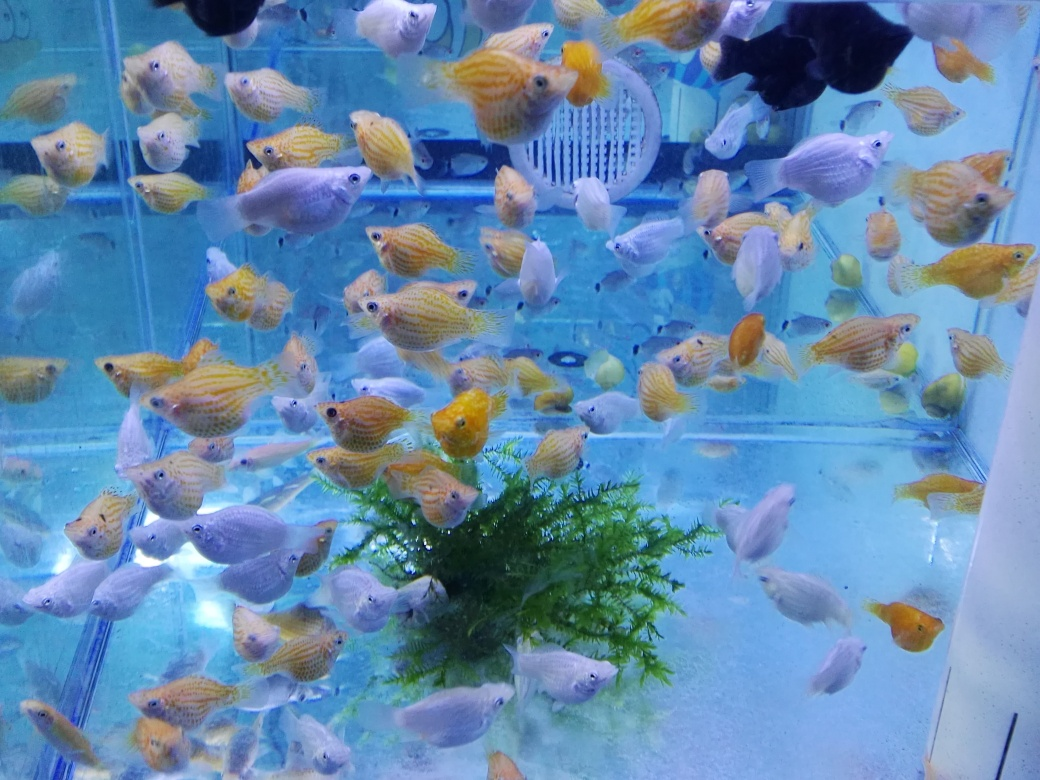Can you tell me about the types of fish in this aquarium? The aquarium appears to be home to cichlids, identified by their diverse body shapes and patterns. Some have vibrant yellow stripes, while others are more subdued in color. It's a freshwater tank, quite populous, indicating a well-maintained environment with ample space for the fish to swim and flourish. 